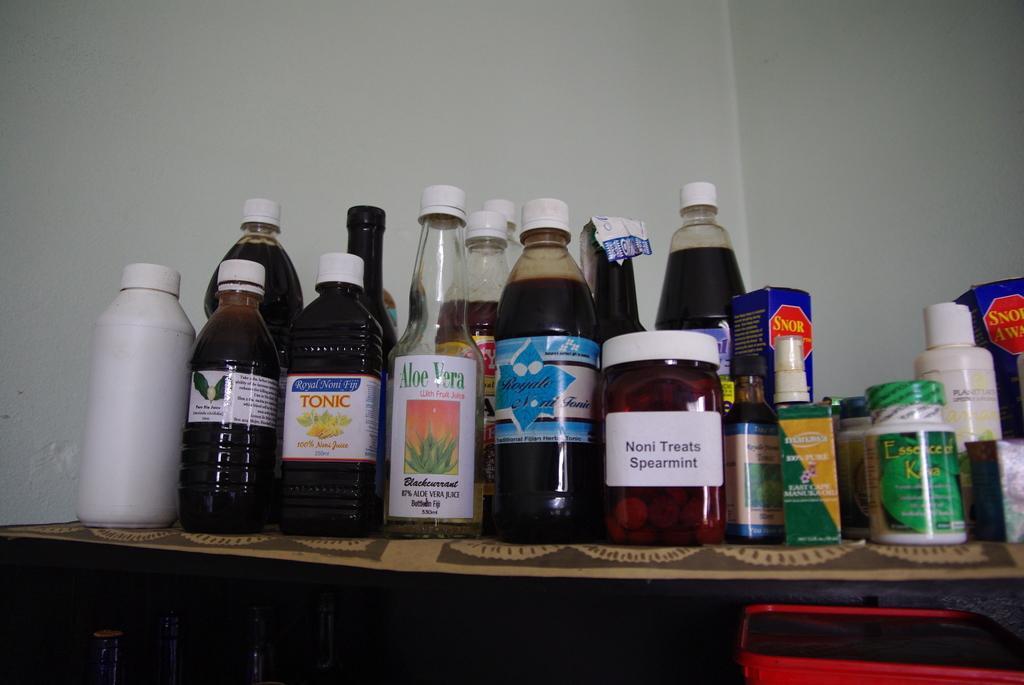Please provide a concise description of this image. on a table there are many bottles. on a bottle aloe vera is written. behind it there is a white wall. 